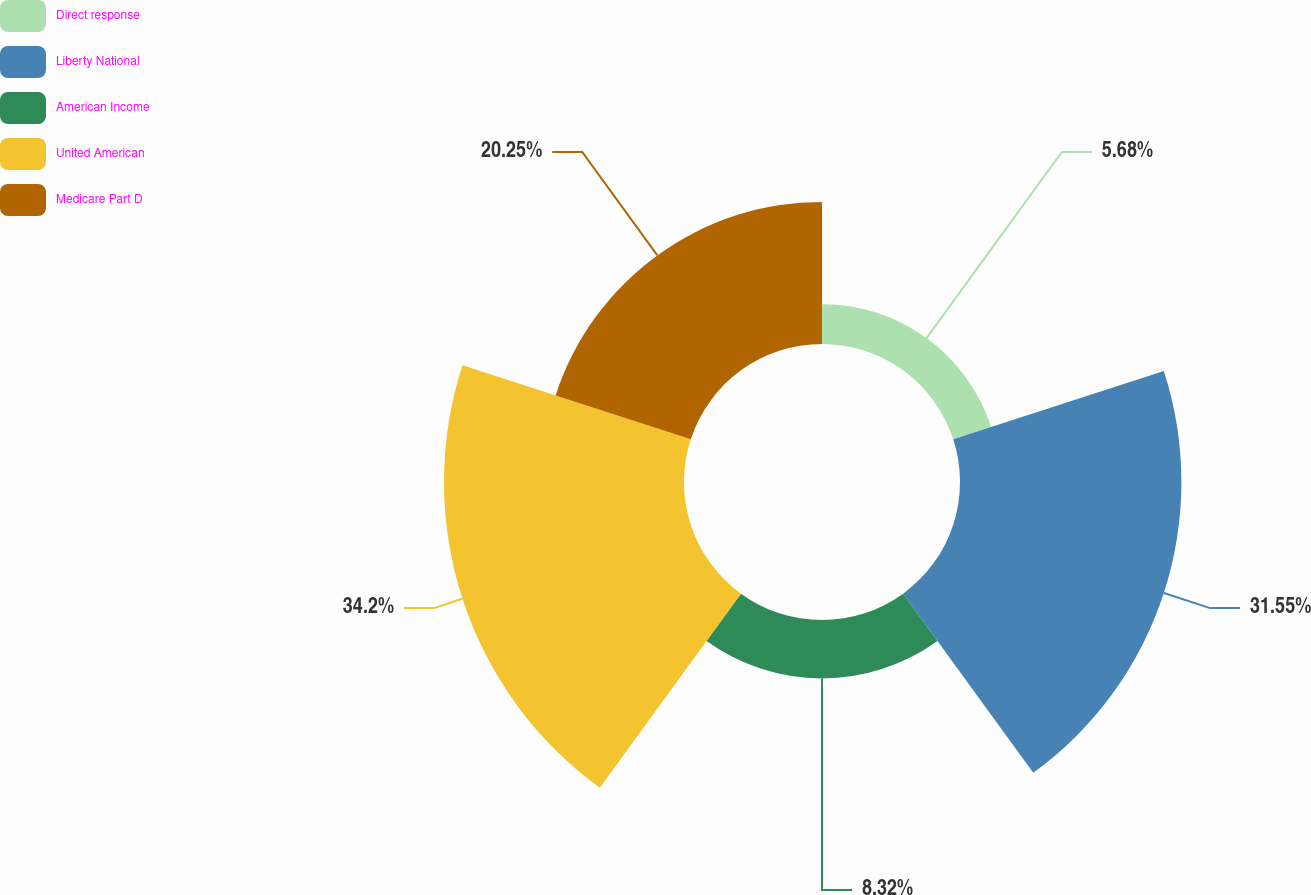<chart> <loc_0><loc_0><loc_500><loc_500><pie_chart><fcel>Direct response<fcel>Liberty National<fcel>American Income<fcel>United American<fcel>Medicare Part D<nl><fcel>5.68%<fcel>31.55%<fcel>8.32%<fcel>34.2%<fcel>20.25%<nl></chart> 